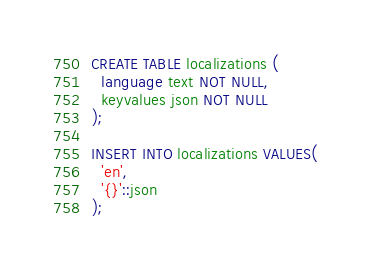<code> <loc_0><loc_0><loc_500><loc_500><_SQL_>CREATE TABLE localizations (
  language text NOT NULL,
  keyvalues json NOT NULL
);

INSERT INTO localizations VALUES(
  'en',
  '{}'::json
);
</code> 